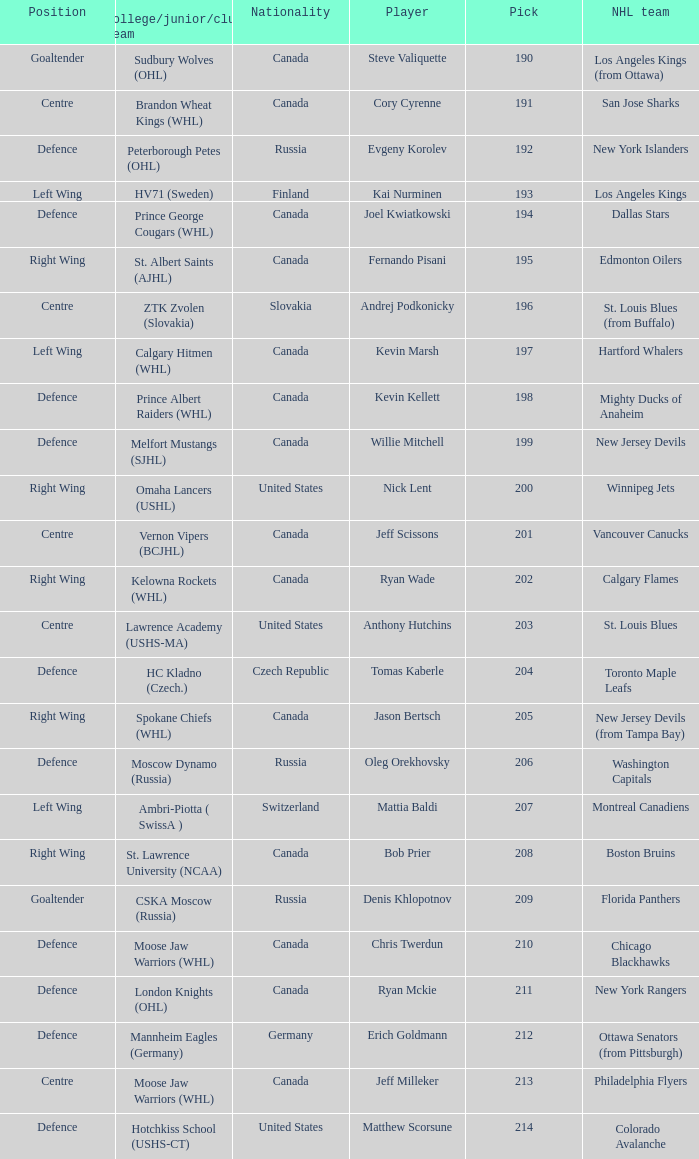Name the college for andrej podkonicky ZTK Zvolen (Slovakia). 